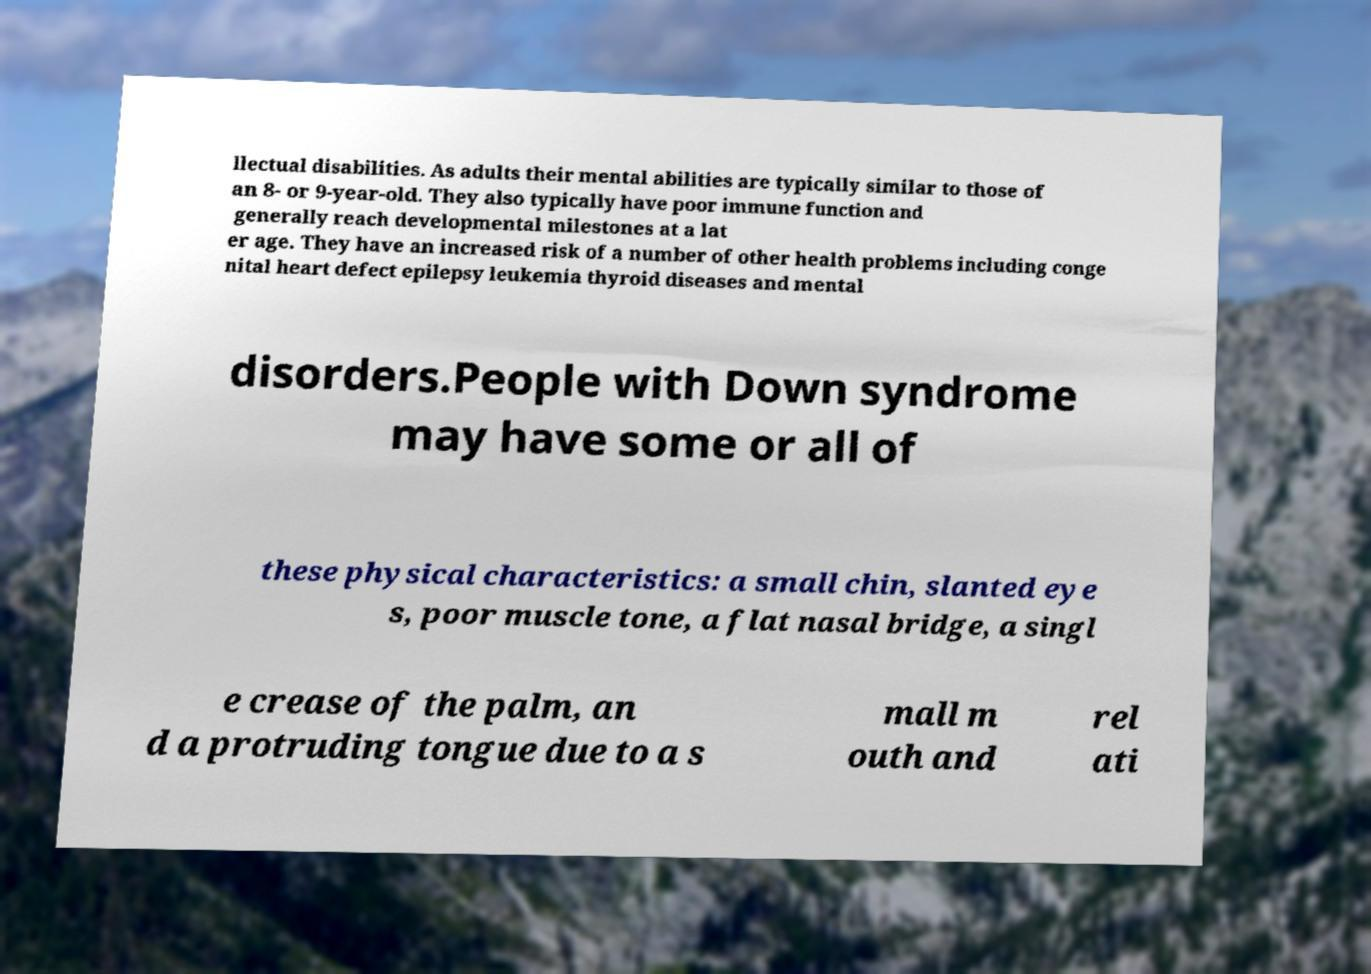What messages or text are displayed in this image? I need them in a readable, typed format. llectual disabilities. As adults their mental abilities are typically similar to those of an 8- or 9-year-old. They also typically have poor immune function and generally reach developmental milestones at a lat er age. They have an increased risk of a number of other health problems including conge nital heart defect epilepsy leukemia thyroid diseases and mental disorders.People with Down syndrome may have some or all of these physical characteristics: a small chin, slanted eye s, poor muscle tone, a flat nasal bridge, a singl e crease of the palm, an d a protruding tongue due to a s mall m outh and rel ati 